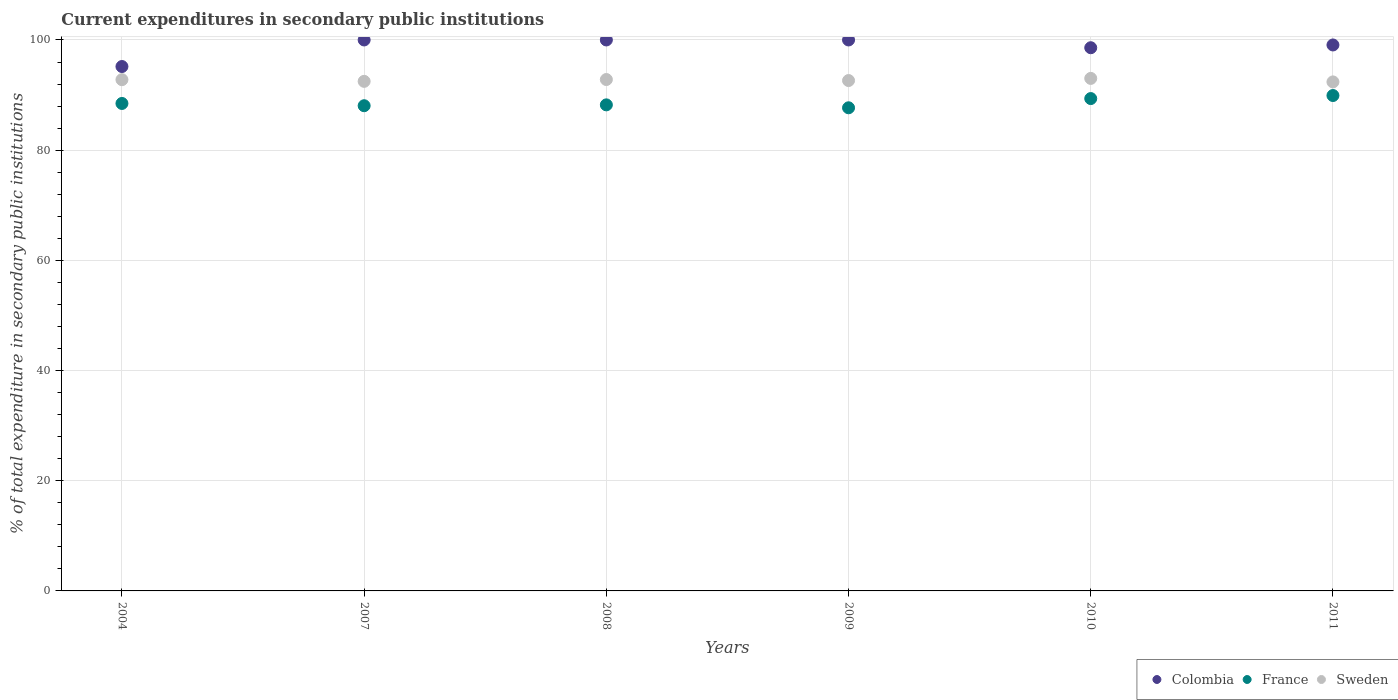What is the current expenditures in secondary public institutions in Sweden in 2007?
Your answer should be very brief. 92.49. Across all years, what is the maximum current expenditures in secondary public institutions in France?
Make the answer very short. 89.92. Across all years, what is the minimum current expenditures in secondary public institutions in France?
Offer a very short reply. 87.69. What is the total current expenditures in secondary public institutions in Sweden in the graph?
Keep it short and to the point. 556.15. What is the difference between the current expenditures in secondary public institutions in France in 2008 and that in 2010?
Keep it short and to the point. -1.14. What is the difference between the current expenditures in secondary public institutions in Sweden in 2007 and the current expenditures in secondary public institutions in Colombia in 2008?
Your answer should be very brief. -7.51. What is the average current expenditures in secondary public institutions in Colombia per year?
Your answer should be compact. 98.81. In the year 2009, what is the difference between the current expenditures in secondary public institutions in Colombia and current expenditures in secondary public institutions in France?
Your response must be concise. 12.31. In how many years, is the current expenditures in secondary public institutions in Sweden greater than 52 %?
Offer a terse response. 6. What is the ratio of the current expenditures in secondary public institutions in France in 2009 to that in 2010?
Keep it short and to the point. 0.98. Is the difference between the current expenditures in secondary public institutions in Colombia in 2004 and 2011 greater than the difference between the current expenditures in secondary public institutions in France in 2004 and 2011?
Offer a very short reply. No. What is the difference between the highest and the second highest current expenditures in secondary public institutions in France?
Offer a terse response. 0.55. What is the difference between the highest and the lowest current expenditures in secondary public institutions in Colombia?
Your response must be concise. 4.82. Is the sum of the current expenditures in secondary public institutions in Colombia in 2004 and 2007 greater than the maximum current expenditures in secondary public institutions in Sweden across all years?
Offer a terse response. Yes. Does the current expenditures in secondary public institutions in Colombia monotonically increase over the years?
Your answer should be very brief. No. Is the current expenditures in secondary public institutions in Colombia strictly greater than the current expenditures in secondary public institutions in France over the years?
Your response must be concise. Yes. Is the current expenditures in secondary public institutions in France strictly less than the current expenditures in secondary public institutions in Colombia over the years?
Make the answer very short. Yes. What is the difference between two consecutive major ticks on the Y-axis?
Ensure brevity in your answer.  20. Does the graph contain any zero values?
Your answer should be compact. No. How are the legend labels stacked?
Make the answer very short. Horizontal. What is the title of the graph?
Your answer should be very brief. Current expenditures in secondary public institutions. What is the label or title of the Y-axis?
Ensure brevity in your answer.  % of total expenditure in secondary public institutions. What is the % of total expenditure in secondary public institutions of Colombia in 2004?
Provide a short and direct response. 95.18. What is the % of total expenditure in secondary public institutions in France in 2004?
Your answer should be compact. 88.48. What is the % of total expenditure in secondary public institutions of Sweden in 2004?
Provide a succinct answer. 92.79. What is the % of total expenditure in secondary public institutions of France in 2007?
Your answer should be compact. 88.07. What is the % of total expenditure in secondary public institutions of Sweden in 2007?
Your answer should be compact. 92.49. What is the % of total expenditure in secondary public institutions in Colombia in 2008?
Your answer should be compact. 100. What is the % of total expenditure in secondary public institutions in France in 2008?
Offer a very short reply. 88.22. What is the % of total expenditure in secondary public institutions in Sweden in 2008?
Your response must be concise. 92.82. What is the % of total expenditure in secondary public institutions in France in 2009?
Provide a succinct answer. 87.69. What is the % of total expenditure in secondary public institutions of Sweden in 2009?
Provide a short and direct response. 92.63. What is the % of total expenditure in secondary public institutions of Colombia in 2010?
Your answer should be compact. 98.59. What is the % of total expenditure in secondary public institutions of France in 2010?
Provide a succinct answer. 89.36. What is the % of total expenditure in secondary public institutions of Sweden in 2010?
Offer a very short reply. 93.02. What is the % of total expenditure in secondary public institutions of Colombia in 2011?
Your answer should be very brief. 99.09. What is the % of total expenditure in secondary public institutions of France in 2011?
Your response must be concise. 89.92. What is the % of total expenditure in secondary public institutions of Sweden in 2011?
Provide a short and direct response. 92.39. Across all years, what is the maximum % of total expenditure in secondary public institutions in France?
Offer a very short reply. 89.92. Across all years, what is the maximum % of total expenditure in secondary public institutions of Sweden?
Provide a succinct answer. 93.02. Across all years, what is the minimum % of total expenditure in secondary public institutions of Colombia?
Keep it short and to the point. 95.18. Across all years, what is the minimum % of total expenditure in secondary public institutions of France?
Offer a very short reply. 87.69. Across all years, what is the minimum % of total expenditure in secondary public institutions in Sweden?
Keep it short and to the point. 92.39. What is the total % of total expenditure in secondary public institutions in Colombia in the graph?
Offer a very short reply. 592.86. What is the total % of total expenditure in secondary public institutions in France in the graph?
Your answer should be compact. 531.73. What is the total % of total expenditure in secondary public institutions of Sweden in the graph?
Give a very brief answer. 556.15. What is the difference between the % of total expenditure in secondary public institutions in Colombia in 2004 and that in 2007?
Make the answer very short. -4.82. What is the difference between the % of total expenditure in secondary public institutions in France in 2004 and that in 2007?
Make the answer very short. 0.41. What is the difference between the % of total expenditure in secondary public institutions in Sweden in 2004 and that in 2007?
Provide a short and direct response. 0.3. What is the difference between the % of total expenditure in secondary public institutions in Colombia in 2004 and that in 2008?
Keep it short and to the point. -4.82. What is the difference between the % of total expenditure in secondary public institutions in France in 2004 and that in 2008?
Offer a terse response. 0.25. What is the difference between the % of total expenditure in secondary public institutions of Sweden in 2004 and that in 2008?
Make the answer very short. -0.03. What is the difference between the % of total expenditure in secondary public institutions of Colombia in 2004 and that in 2009?
Your answer should be very brief. -4.82. What is the difference between the % of total expenditure in secondary public institutions of France in 2004 and that in 2009?
Offer a terse response. 0.79. What is the difference between the % of total expenditure in secondary public institutions in Sweden in 2004 and that in 2009?
Ensure brevity in your answer.  0.16. What is the difference between the % of total expenditure in secondary public institutions in Colombia in 2004 and that in 2010?
Offer a terse response. -3.41. What is the difference between the % of total expenditure in secondary public institutions of France in 2004 and that in 2010?
Your response must be concise. -0.89. What is the difference between the % of total expenditure in secondary public institutions of Sweden in 2004 and that in 2010?
Your answer should be very brief. -0.23. What is the difference between the % of total expenditure in secondary public institutions of Colombia in 2004 and that in 2011?
Ensure brevity in your answer.  -3.91. What is the difference between the % of total expenditure in secondary public institutions in France in 2004 and that in 2011?
Ensure brevity in your answer.  -1.44. What is the difference between the % of total expenditure in secondary public institutions of Sweden in 2004 and that in 2011?
Make the answer very short. 0.41. What is the difference between the % of total expenditure in secondary public institutions in France in 2007 and that in 2008?
Your answer should be compact. -0.16. What is the difference between the % of total expenditure in secondary public institutions of Sweden in 2007 and that in 2008?
Your answer should be compact. -0.33. What is the difference between the % of total expenditure in secondary public institutions of Colombia in 2007 and that in 2009?
Provide a succinct answer. 0. What is the difference between the % of total expenditure in secondary public institutions of France in 2007 and that in 2009?
Provide a succinct answer. 0.38. What is the difference between the % of total expenditure in secondary public institutions of Sweden in 2007 and that in 2009?
Your answer should be very brief. -0.15. What is the difference between the % of total expenditure in secondary public institutions of Colombia in 2007 and that in 2010?
Your answer should be very brief. 1.41. What is the difference between the % of total expenditure in secondary public institutions in France in 2007 and that in 2010?
Offer a very short reply. -1.3. What is the difference between the % of total expenditure in secondary public institutions in Sweden in 2007 and that in 2010?
Make the answer very short. -0.54. What is the difference between the % of total expenditure in secondary public institutions of Colombia in 2007 and that in 2011?
Offer a very short reply. 0.91. What is the difference between the % of total expenditure in secondary public institutions in France in 2007 and that in 2011?
Your answer should be compact. -1.85. What is the difference between the % of total expenditure in secondary public institutions in Sweden in 2007 and that in 2011?
Keep it short and to the point. 0.1. What is the difference between the % of total expenditure in secondary public institutions in Colombia in 2008 and that in 2009?
Ensure brevity in your answer.  0. What is the difference between the % of total expenditure in secondary public institutions in France in 2008 and that in 2009?
Your answer should be very brief. 0.53. What is the difference between the % of total expenditure in secondary public institutions of Sweden in 2008 and that in 2009?
Provide a succinct answer. 0.19. What is the difference between the % of total expenditure in secondary public institutions of Colombia in 2008 and that in 2010?
Provide a short and direct response. 1.41. What is the difference between the % of total expenditure in secondary public institutions of France in 2008 and that in 2010?
Make the answer very short. -1.14. What is the difference between the % of total expenditure in secondary public institutions of Sweden in 2008 and that in 2010?
Your response must be concise. -0.2. What is the difference between the % of total expenditure in secondary public institutions in Colombia in 2008 and that in 2011?
Your response must be concise. 0.91. What is the difference between the % of total expenditure in secondary public institutions of France in 2008 and that in 2011?
Ensure brevity in your answer.  -1.69. What is the difference between the % of total expenditure in secondary public institutions of Sweden in 2008 and that in 2011?
Provide a short and direct response. 0.43. What is the difference between the % of total expenditure in secondary public institutions in Colombia in 2009 and that in 2010?
Your answer should be compact. 1.41. What is the difference between the % of total expenditure in secondary public institutions in France in 2009 and that in 2010?
Offer a terse response. -1.67. What is the difference between the % of total expenditure in secondary public institutions in Sweden in 2009 and that in 2010?
Your answer should be very brief. -0.39. What is the difference between the % of total expenditure in secondary public institutions of Colombia in 2009 and that in 2011?
Make the answer very short. 0.91. What is the difference between the % of total expenditure in secondary public institutions in France in 2009 and that in 2011?
Offer a very short reply. -2.23. What is the difference between the % of total expenditure in secondary public institutions in Sweden in 2009 and that in 2011?
Offer a very short reply. 0.25. What is the difference between the % of total expenditure in secondary public institutions in Colombia in 2010 and that in 2011?
Give a very brief answer. -0.5. What is the difference between the % of total expenditure in secondary public institutions of France in 2010 and that in 2011?
Offer a terse response. -0.55. What is the difference between the % of total expenditure in secondary public institutions of Sweden in 2010 and that in 2011?
Keep it short and to the point. 0.64. What is the difference between the % of total expenditure in secondary public institutions in Colombia in 2004 and the % of total expenditure in secondary public institutions in France in 2007?
Make the answer very short. 7.11. What is the difference between the % of total expenditure in secondary public institutions in Colombia in 2004 and the % of total expenditure in secondary public institutions in Sweden in 2007?
Provide a succinct answer. 2.69. What is the difference between the % of total expenditure in secondary public institutions in France in 2004 and the % of total expenditure in secondary public institutions in Sweden in 2007?
Keep it short and to the point. -4.01. What is the difference between the % of total expenditure in secondary public institutions in Colombia in 2004 and the % of total expenditure in secondary public institutions in France in 2008?
Ensure brevity in your answer.  6.96. What is the difference between the % of total expenditure in secondary public institutions of Colombia in 2004 and the % of total expenditure in secondary public institutions of Sweden in 2008?
Provide a succinct answer. 2.36. What is the difference between the % of total expenditure in secondary public institutions of France in 2004 and the % of total expenditure in secondary public institutions of Sweden in 2008?
Keep it short and to the point. -4.34. What is the difference between the % of total expenditure in secondary public institutions of Colombia in 2004 and the % of total expenditure in secondary public institutions of France in 2009?
Give a very brief answer. 7.49. What is the difference between the % of total expenditure in secondary public institutions in Colombia in 2004 and the % of total expenditure in secondary public institutions in Sweden in 2009?
Give a very brief answer. 2.54. What is the difference between the % of total expenditure in secondary public institutions in France in 2004 and the % of total expenditure in secondary public institutions in Sweden in 2009?
Provide a short and direct response. -4.16. What is the difference between the % of total expenditure in secondary public institutions of Colombia in 2004 and the % of total expenditure in secondary public institutions of France in 2010?
Offer a very short reply. 5.82. What is the difference between the % of total expenditure in secondary public institutions of Colombia in 2004 and the % of total expenditure in secondary public institutions of Sweden in 2010?
Ensure brevity in your answer.  2.15. What is the difference between the % of total expenditure in secondary public institutions of France in 2004 and the % of total expenditure in secondary public institutions of Sweden in 2010?
Ensure brevity in your answer.  -4.55. What is the difference between the % of total expenditure in secondary public institutions in Colombia in 2004 and the % of total expenditure in secondary public institutions in France in 2011?
Offer a very short reply. 5.26. What is the difference between the % of total expenditure in secondary public institutions in Colombia in 2004 and the % of total expenditure in secondary public institutions in Sweden in 2011?
Ensure brevity in your answer.  2.79. What is the difference between the % of total expenditure in secondary public institutions in France in 2004 and the % of total expenditure in secondary public institutions in Sweden in 2011?
Ensure brevity in your answer.  -3.91. What is the difference between the % of total expenditure in secondary public institutions of Colombia in 2007 and the % of total expenditure in secondary public institutions of France in 2008?
Provide a succinct answer. 11.78. What is the difference between the % of total expenditure in secondary public institutions in Colombia in 2007 and the % of total expenditure in secondary public institutions in Sweden in 2008?
Your answer should be very brief. 7.18. What is the difference between the % of total expenditure in secondary public institutions in France in 2007 and the % of total expenditure in secondary public institutions in Sweden in 2008?
Your response must be concise. -4.75. What is the difference between the % of total expenditure in secondary public institutions in Colombia in 2007 and the % of total expenditure in secondary public institutions in France in 2009?
Provide a succinct answer. 12.31. What is the difference between the % of total expenditure in secondary public institutions in Colombia in 2007 and the % of total expenditure in secondary public institutions in Sweden in 2009?
Provide a short and direct response. 7.37. What is the difference between the % of total expenditure in secondary public institutions of France in 2007 and the % of total expenditure in secondary public institutions of Sweden in 2009?
Offer a terse response. -4.57. What is the difference between the % of total expenditure in secondary public institutions in Colombia in 2007 and the % of total expenditure in secondary public institutions in France in 2010?
Make the answer very short. 10.64. What is the difference between the % of total expenditure in secondary public institutions of Colombia in 2007 and the % of total expenditure in secondary public institutions of Sweden in 2010?
Your response must be concise. 6.98. What is the difference between the % of total expenditure in secondary public institutions in France in 2007 and the % of total expenditure in secondary public institutions in Sweden in 2010?
Give a very brief answer. -4.96. What is the difference between the % of total expenditure in secondary public institutions in Colombia in 2007 and the % of total expenditure in secondary public institutions in France in 2011?
Your response must be concise. 10.08. What is the difference between the % of total expenditure in secondary public institutions in Colombia in 2007 and the % of total expenditure in secondary public institutions in Sweden in 2011?
Offer a terse response. 7.61. What is the difference between the % of total expenditure in secondary public institutions in France in 2007 and the % of total expenditure in secondary public institutions in Sweden in 2011?
Make the answer very short. -4.32. What is the difference between the % of total expenditure in secondary public institutions of Colombia in 2008 and the % of total expenditure in secondary public institutions of France in 2009?
Provide a short and direct response. 12.31. What is the difference between the % of total expenditure in secondary public institutions of Colombia in 2008 and the % of total expenditure in secondary public institutions of Sweden in 2009?
Offer a terse response. 7.37. What is the difference between the % of total expenditure in secondary public institutions in France in 2008 and the % of total expenditure in secondary public institutions in Sweden in 2009?
Provide a short and direct response. -4.41. What is the difference between the % of total expenditure in secondary public institutions of Colombia in 2008 and the % of total expenditure in secondary public institutions of France in 2010?
Offer a very short reply. 10.64. What is the difference between the % of total expenditure in secondary public institutions of Colombia in 2008 and the % of total expenditure in secondary public institutions of Sweden in 2010?
Ensure brevity in your answer.  6.98. What is the difference between the % of total expenditure in secondary public institutions of France in 2008 and the % of total expenditure in secondary public institutions of Sweden in 2010?
Your answer should be compact. -4.8. What is the difference between the % of total expenditure in secondary public institutions of Colombia in 2008 and the % of total expenditure in secondary public institutions of France in 2011?
Provide a succinct answer. 10.08. What is the difference between the % of total expenditure in secondary public institutions of Colombia in 2008 and the % of total expenditure in secondary public institutions of Sweden in 2011?
Your answer should be very brief. 7.61. What is the difference between the % of total expenditure in secondary public institutions in France in 2008 and the % of total expenditure in secondary public institutions in Sweden in 2011?
Keep it short and to the point. -4.17. What is the difference between the % of total expenditure in secondary public institutions in Colombia in 2009 and the % of total expenditure in secondary public institutions in France in 2010?
Provide a succinct answer. 10.64. What is the difference between the % of total expenditure in secondary public institutions in Colombia in 2009 and the % of total expenditure in secondary public institutions in Sweden in 2010?
Give a very brief answer. 6.98. What is the difference between the % of total expenditure in secondary public institutions of France in 2009 and the % of total expenditure in secondary public institutions of Sweden in 2010?
Offer a very short reply. -5.34. What is the difference between the % of total expenditure in secondary public institutions of Colombia in 2009 and the % of total expenditure in secondary public institutions of France in 2011?
Your answer should be very brief. 10.08. What is the difference between the % of total expenditure in secondary public institutions in Colombia in 2009 and the % of total expenditure in secondary public institutions in Sweden in 2011?
Give a very brief answer. 7.61. What is the difference between the % of total expenditure in secondary public institutions of France in 2009 and the % of total expenditure in secondary public institutions of Sweden in 2011?
Your answer should be compact. -4.7. What is the difference between the % of total expenditure in secondary public institutions of Colombia in 2010 and the % of total expenditure in secondary public institutions of France in 2011?
Provide a short and direct response. 8.68. What is the difference between the % of total expenditure in secondary public institutions of Colombia in 2010 and the % of total expenditure in secondary public institutions of Sweden in 2011?
Make the answer very short. 6.2. What is the difference between the % of total expenditure in secondary public institutions of France in 2010 and the % of total expenditure in secondary public institutions of Sweden in 2011?
Offer a terse response. -3.02. What is the average % of total expenditure in secondary public institutions of Colombia per year?
Provide a short and direct response. 98.81. What is the average % of total expenditure in secondary public institutions in France per year?
Your answer should be compact. 88.62. What is the average % of total expenditure in secondary public institutions of Sweden per year?
Provide a succinct answer. 92.69. In the year 2004, what is the difference between the % of total expenditure in secondary public institutions in Colombia and % of total expenditure in secondary public institutions in France?
Provide a short and direct response. 6.7. In the year 2004, what is the difference between the % of total expenditure in secondary public institutions of Colombia and % of total expenditure in secondary public institutions of Sweden?
Keep it short and to the point. 2.39. In the year 2004, what is the difference between the % of total expenditure in secondary public institutions in France and % of total expenditure in secondary public institutions in Sweden?
Provide a short and direct response. -4.32. In the year 2007, what is the difference between the % of total expenditure in secondary public institutions of Colombia and % of total expenditure in secondary public institutions of France?
Give a very brief answer. 11.93. In the year 2007, what is the difference between the % of total expenditure in secondary public institutions in Colombia and % of total expenditure in secondary public institutions in Sweden?
Your answer should be compact. 7.51. In the year 2007, what is the difference between the % of total expenditure in secondary public institutions of France and % of total expenditure in secondary public institutions of Sweden?
Your response must be concise. -4.42. In the year 2008, what is the difference between the % of total expenditure in secondary public institutions in Colombia and % of total expenditure in secondary public institutions in France?
Keep it short and to the point. 11.78. In the year 2008, what is the difference between the % of total expenditure in secondary public institutions in Colombia and % of total expenditure in secondary public institutions in Sweden?
Ensure brevity in your answer.  7.18. In the year 2008, what is the difference between the % of total expenditure in secondary public institutions of France and % of total expenditure in secondary public institutions of Sweden?
Make the answer very short. -4.6. In the year 2009, what is the difference between the % of total expenditure in secondary public institutions of Colombia and % of total expenditure in secondary public institutions of France?
Give a very brief answer. 12.31. In the year 2009, what is the difference between the % of total expenditure in secondary public institutions in Colombia and % of total expenditure in secondary public institutions in Sweden?
Offer a terse response. 7.37. In the year 2009, what is the difference between the % of total expenditure in secondary public institutions of France and % of total expenditure in secondary public institutions of Sweden?
Ensure brevity in your answer.  -4.95. In the year 2010, what is the difference between the % of total expenditure in secondary public institutions of Colombia and % of total expenditure in secondary public institutions of France?
Offer a very short reply. 9.23. In the year 2010, what is the difference between the % of total expenditure in secondary public institutions in Colombia and % of total expenditure in secondary public institutions in Sweden?
Make the answer very short. 5.57. In the year 2010, what is the difference between the % of total expenditure in secondary public institutions in France and % of total expenditure in secondary public institutions in Sweden?
Make the answer very short. -3.66. In the year 2011, what is the difference between the % of total expenditure in secondary public institutions of Colombia and % of total expenditure in secondary public institutions of France?
Your answer should be very brief. 9.18. In the year 2011, what is the difference between the % of total expenditure in secondary public institutions of Colombia and % of total expenditure in secondary public institutions of Sweden?
Offer a terse response. 6.71. In the year 2011, what is the difference between the % of total expenditure in secondary public institutions of France and % of total expenditure in secondary public institutions of Sweden?
Give a very brief answer. -2.47. What is the ratio of the % of total expenditure in secondary public institutions of Colombia in 2004 to that in 2007?
Ensure brevity in your answer.  0.95. What is the ratio of the % of total expenditure in secondary public institutions of Colombia in 2004 to that in 2008?
Your answer should be very brief. 0.95. What is the ratio of the % of total expenditure in secondary public institutions in France in 2004 to that in 2008?
Provide a short and direct response. 1. What is the ratio of the % of total expenditure in secondary public institutions of Colombia in 2004 to that in 2009?
Keep it short and to the point. 0.95. What is the ratio of the % of total expenditure in secondary public institutions in Colombia in 2004 to that in 2010?
Give a very brief answer. 0.97. What is the ratio of the % of total expenditure in secondary public institutions in France in 2004 to that in 2010?
Give a very brief answer. 0.99. What is the ratio of the % of total expenditure in secondary public institutions in Colombia in 2004 to that in 2011?
Make the answer very short. 0.96. What is the ratio of the % of total expenditure in secondary public institutions in Colombia in 2007 to that in 2008?
Keep it short and to the point. 1. What is the ratio of the % of total expenditure in secondary public institutions of France in 2007 to that in 2009?
Keep it short and to the point. 1. What is the ratio of the % of total expenditure in secondary public institutions in Colombia in 2007 to that in 2010?
Make the answer very short. 1.01. What is the ratio of the % of total expenditure in secondary public institutions in France in 2007 to that in 2010?
Give a very brief answer. 0.99. What is the ratio of the % of total expenditure in secondary public institutions in Colombia in 2007 to that in 2011?
Provide a succinct answer. 1.01. What is the ratio of the % of total expenditure in secondary public institutions in France in 2007 to that in 2011?
Provide a succinct answer. 0.98. What is the ratio of the % of total expenditure in secondary public institutions of Colombia in 2008 to that in 2009?
Provide a succinct answer. 1. What is the ratio of the % of total expenditure in secondary public institutions in Colombia in 2008 to that in 2010?
Offer a very short reply. 1.01. What is the ratio of the % of total expenditure in secondary public institutions in France in 2008 to that in 2010?
Offer a very short reply. 0.99. What is the ratio of the % of total expenditure in secondary public institutions in Sweden in 2008 to that in 2010?
Offer a very short reply. 1. What is the ratio of the % of total expenditure in secondary public institutions in Colombia in 2008 to that in 2011?
Ensure brevity in your answer.  1.01. What is the ratio of the % of total expenditure in secondary public institutions of France in 2008 to that in 2011?
Your answer should be compact. 0.98. What is the ratio of the % of total expenditure in secondary public institutions in Colombia in 2009 to that in 2010?
Keep it short and to the point. 1.01. What is the ratio of the % of total expenditure in secondary public institutions in France in 2009 to that in 2010?
Your answer should be compact. 0.98. What is the ratio of the % of total expenditure in secondary public institutions of Sweden in 2009 to that in 2010?
Your answer should be compact. 1. What is the ratio of the % of total expenditure in secondary public institutions of Colombia in 2009 to that in 2011?
Ensure brevity in your answer.  1.01. What is the ratio of the % of total expenditure in secondary public institutions of France in 2009 to that in 2011?
Keep it short and to the point. 0.98. What is the ratio of the % of total expenditure in secondary public institutions of Sweden in 2009 to that in 2011?
Make the answer very short. 1. What is the ratio of the % of total expenditure in secondary public institutions of France in 2010 to that in 2011?
Ensure brevity in your answer.  0.99. What is the difference between the highest and the second highest % of total expenditure in secondary public institutions in Colombia?
Offer a very short reply. 0. What is the difference between the highest and the second highest % of total expenditure in secondary public institutions in France?
Ensure brevity in your answer.  0.55. What is the difference between the highest and the second highest % of total expenditure in secondary public institutions of Sweden?
Keep it short and to the point. 0.2. What is the difference between the highest and the lowest % of total expenditure in secondary public institutions in Colombia?
Your response must be concise. 4.82. What is the difference between the highest and the lowest % of total expenditure in secondary public institutions in France?
Ensure brevity in your answer.  2.23. What is the difference between the highest and the lowest % of total expenditure in secondary public institutions in Sweden?
Your answer should be compact. 0.64. 